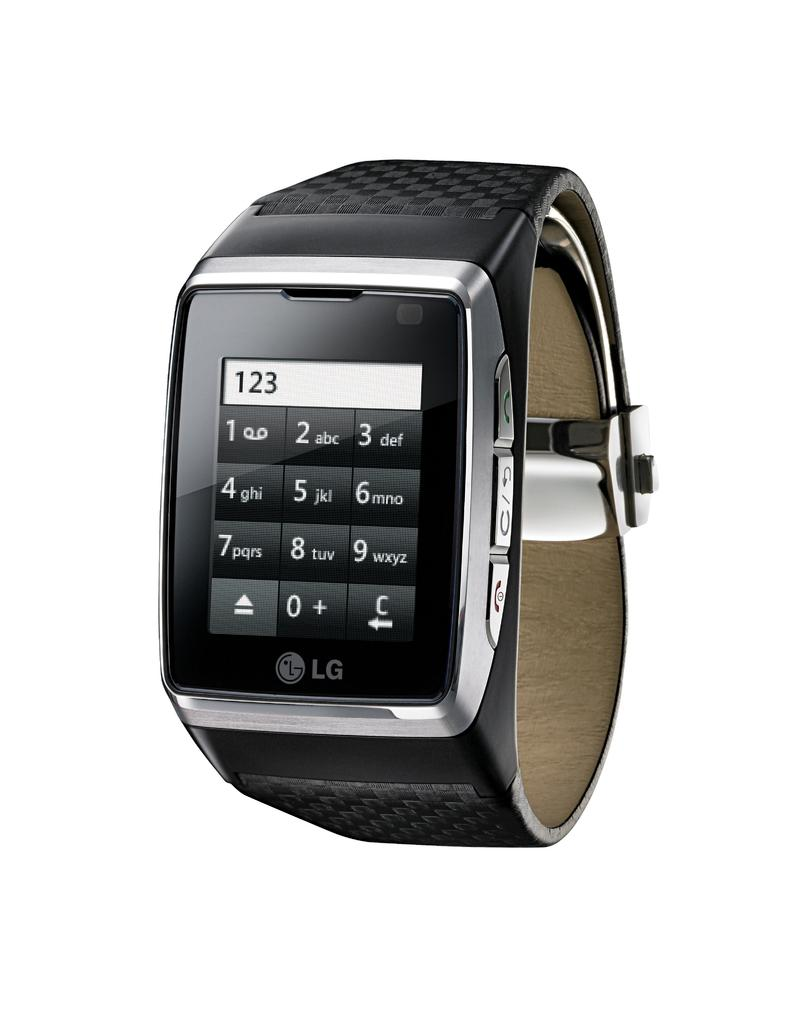<image>
Render a clear and concise summary of the photo. a watch that has 123 on a calculator on it 